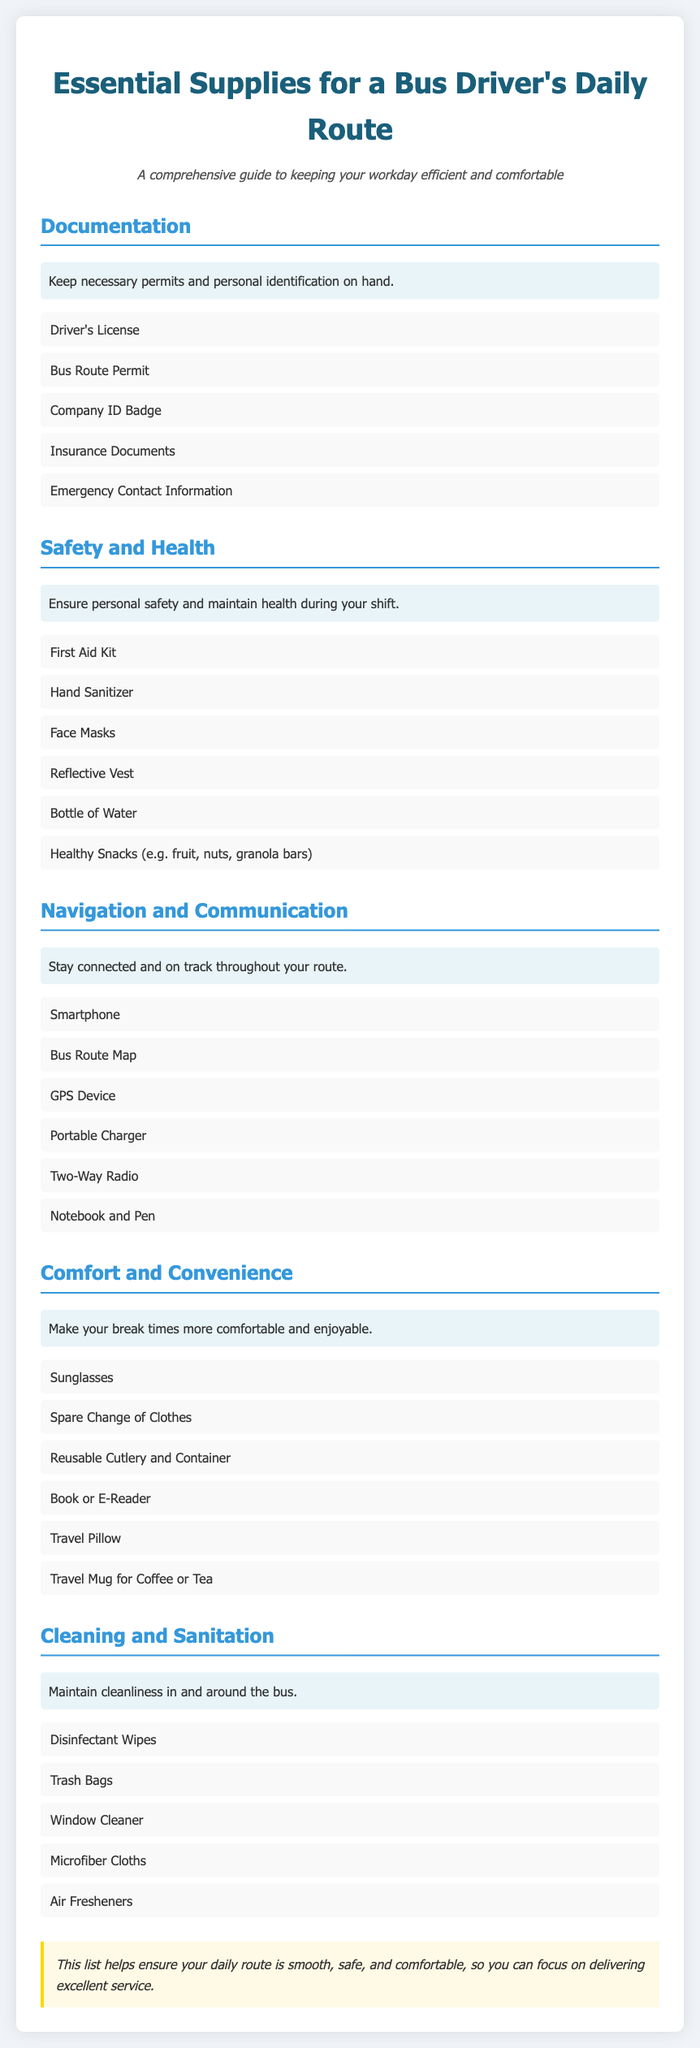what is included in the documentation category? The documentation category includes essential papers and identification for bus drivers.
Answer: Driver's License, Bus Route Permit, Company ID Badge, Insurance Documents, Emergency Contact Information how many items are in the safety and health category? This question requires counting the number of items listed under the safety and health category.
Answer: 6 name one item that promotes comfort and convenience. The comfort and convenience category includes items that enhance the driver's break time.
Answer: Travel Pillow what is the purpose of the first aid kit? The first aid kit helps ensure personal safety and health during shifts.
Answer: Personal safety which item assists with navigation on the route? This question requires identifying an item that aids in navigation during the bus driver's route.
Answer: GPS Device how many categories are listed in the document? This question requires a count of all the categories presented in the packing list.
Answer: 5 what type of items are included in the cleaning and sanitation category? This category includes supplies to maintain cleanliness in and around the bus.
Answer: Disinfectant Wipes, Trash Bags, Window Cleaner, Microfiber Cloths, Air Fresheners what can you use the notebook and pen for? The notebook and pen are useful tools for communication and note-taking while on the route.
Answer: Communication and note-taking what should be used for hydration during breaks? This item ensures that the bus driver stays hydrated during their break.
Answer: Bottle of Water 